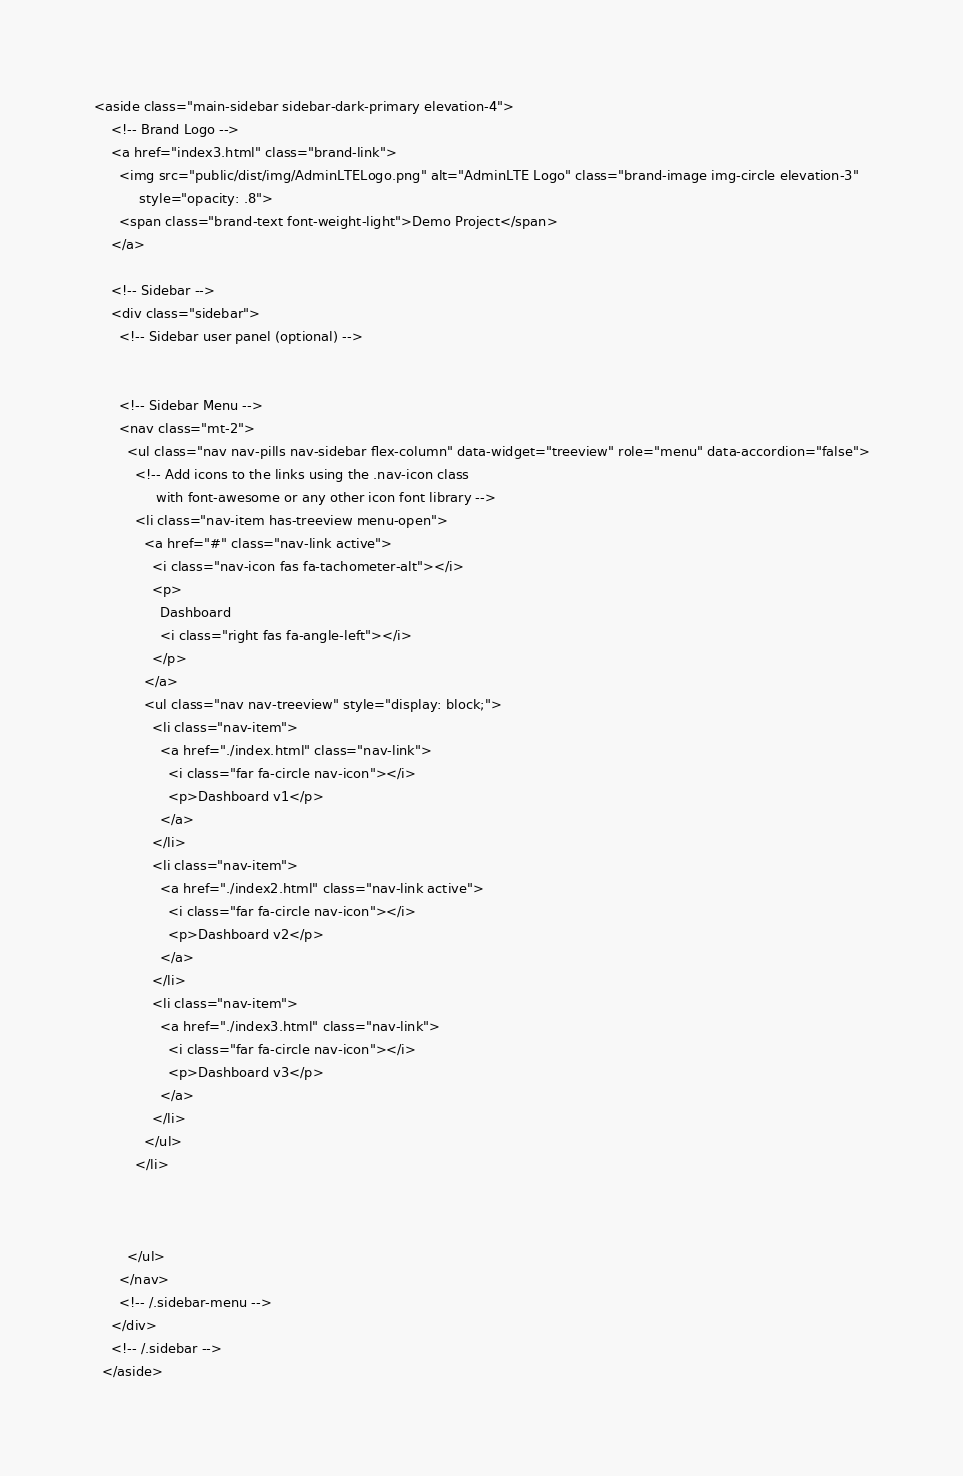Convert code to text. <code><loc_0><loc_0><loc_500><loc_500><_PHP_><aside class="main-sidebar sidebar-dark-primary elevation-4">
    <!-- Brand Logo -->
    <a href="index3.html" class="brand-link">
      <img src="public/dist/img/AdminLTELogo.png" alt="AdminLTE Logo" class="brand-image img-circle elevation-3"
           style="opacity: .8">
      <span class="brand-text font-weight-light">Demo Project</span>
    </a>

    <!-- Sidebar -->
    <div class="sidebar">
      <!-- Sidebar user panel (optional) -->
   

      <!-- Sidebar Menu -->
      <nav class="mt-2">
        <ul class="nav nav-pills nav-sidebar flex-column" data-widget="treeview" role="menu" data-accordion="false">
          <!-- Add icons to the links using the .nav-icon class
               with font-awesome or any other icon font library -->
          <li class="nav-item has-treeview menu-open">
            <a href="#" class="nav-link active">
              <i class="nav-icon fas fa-tachometer-alt"></i>
              <p>
                Dashboard
                <i class="right fas fa-angle-left"></i>
              </p>
            </a>
            <ul class="nav nav-treeview" style="display: block;">
              <li class="nav-item">
                <a href="./index.html" class="nav-link">
                  <i class="far fa-circle nav-icon"></i>
                  <p>Dashboard v1</p>
                </a>
              </li>
              <li class="nav-item">
                <a href="./index2.html" class="nav-link active">
                  <i class="far fa-circle nav-icon"></i>
                  <p>Dashboard v2</p>
                </a>
              </li>
              <li class="nav-item">
                <a href="./index3.html" class="nav-link">
                  <i class="far fa-circle nav-icon"></i>
                  <p>Dashboard v3</p>
                </a>
              </li>
            </ul>
          </li>
   
     
    
        </ul>
      </nav>
      <!-- /.sidebar-menu -->
    </div>
    <!-- /.sidebar -->
  </aside></code> 